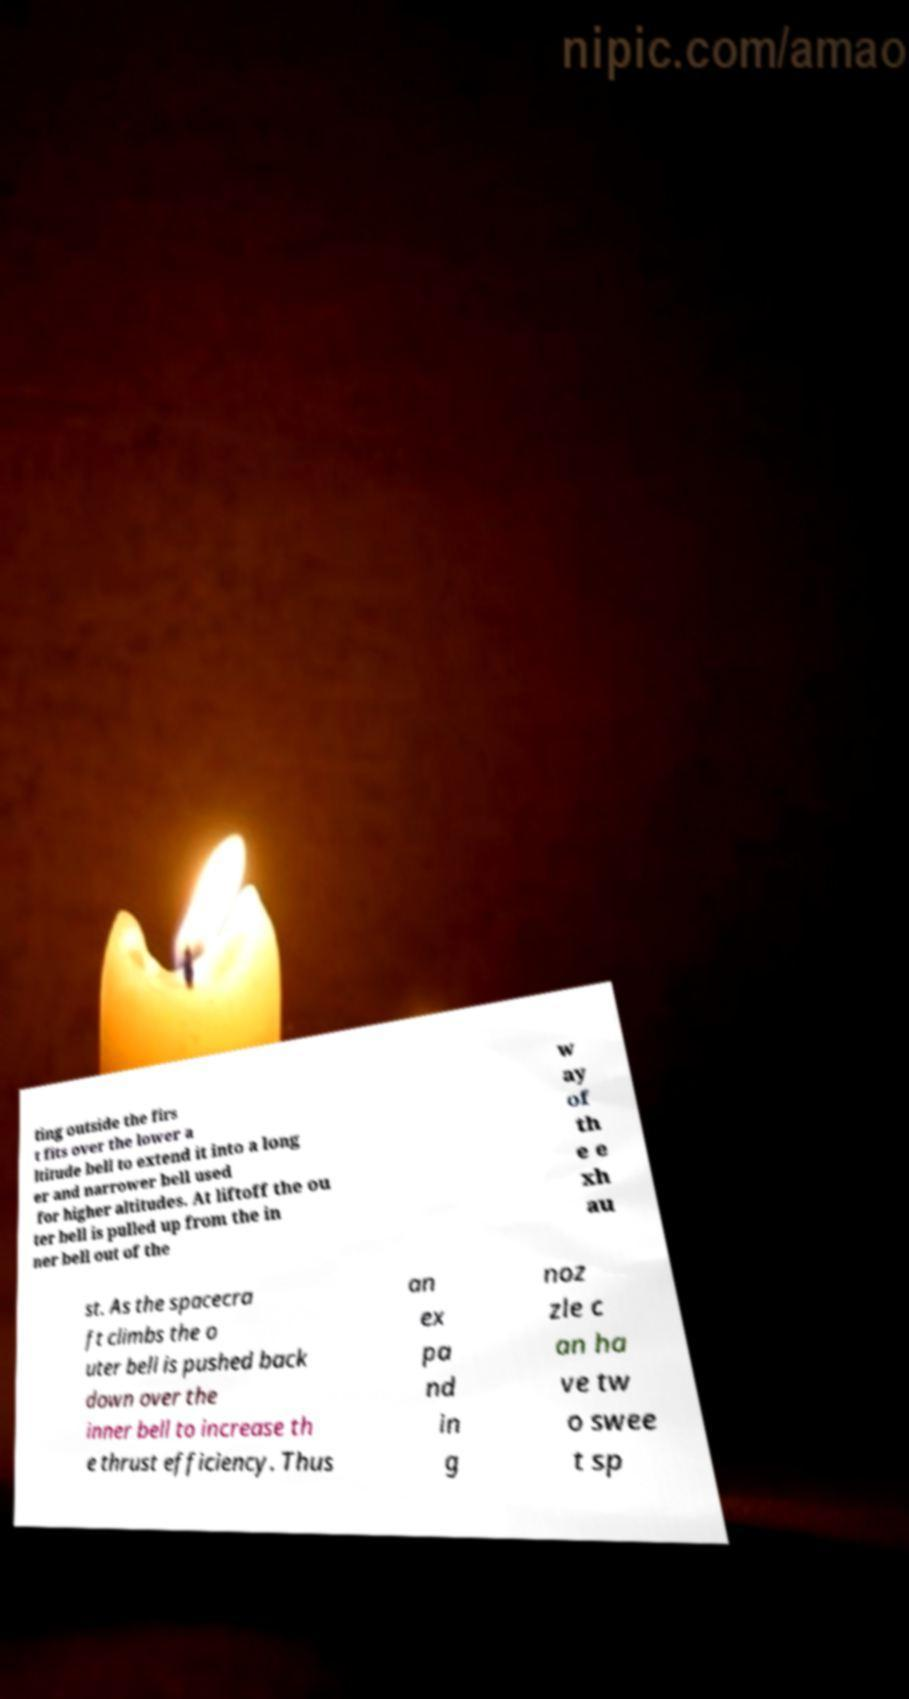Please read and relay the text visible in this image. What does it say? ting outside the firs t fits over the lower a ltitude bell to extend it into a long er and narrower bell used for higher altitudes. At liftoff the ou ter bell is pulled up from the in ner bell out of the w ay of th e e xh au st. As the spacecra ft climbs the o uter bell is pushed back down over the inner bell to increase th e thrust efficiency. Thus an ex pa nd in g noz zle c an ha ve tw o swee t sp 